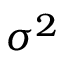Convert formula to latex. <formula><loc_0><loc_0><loc_500><loc_500>\sigma ^ { 2 }</formula> 